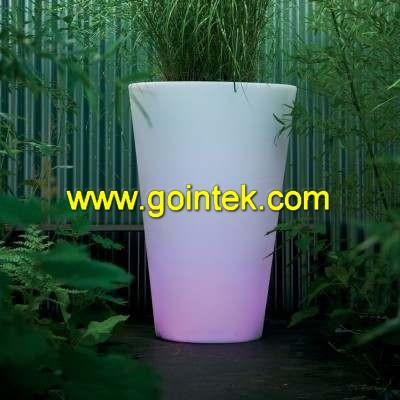Question: how many pots are there?
Choices:
A. Two.
B. Four.
C. Six.
D. One.
Answer with the letter. Answer: D Question: where was the picture taken?
Choices:
A. The garden.
B. By the fountain.
C. By the building.
D. By the grotto.
Answer with the letter. Answer: A 